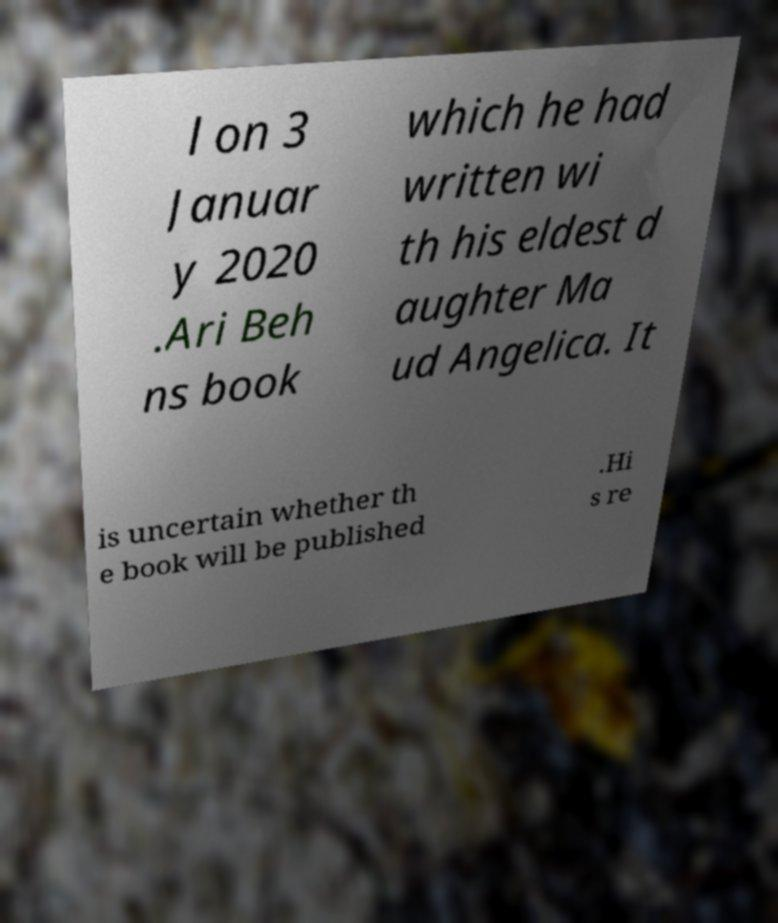For documentation purposes, I need the text within this image transcribed. Could you provide that? l on 3 Januar y 2020 .Ari Beh ns book which he had written wi th his eldest d aughter Ma ud Angelica. It is uncertain whether th e book will be published .Hi s re 